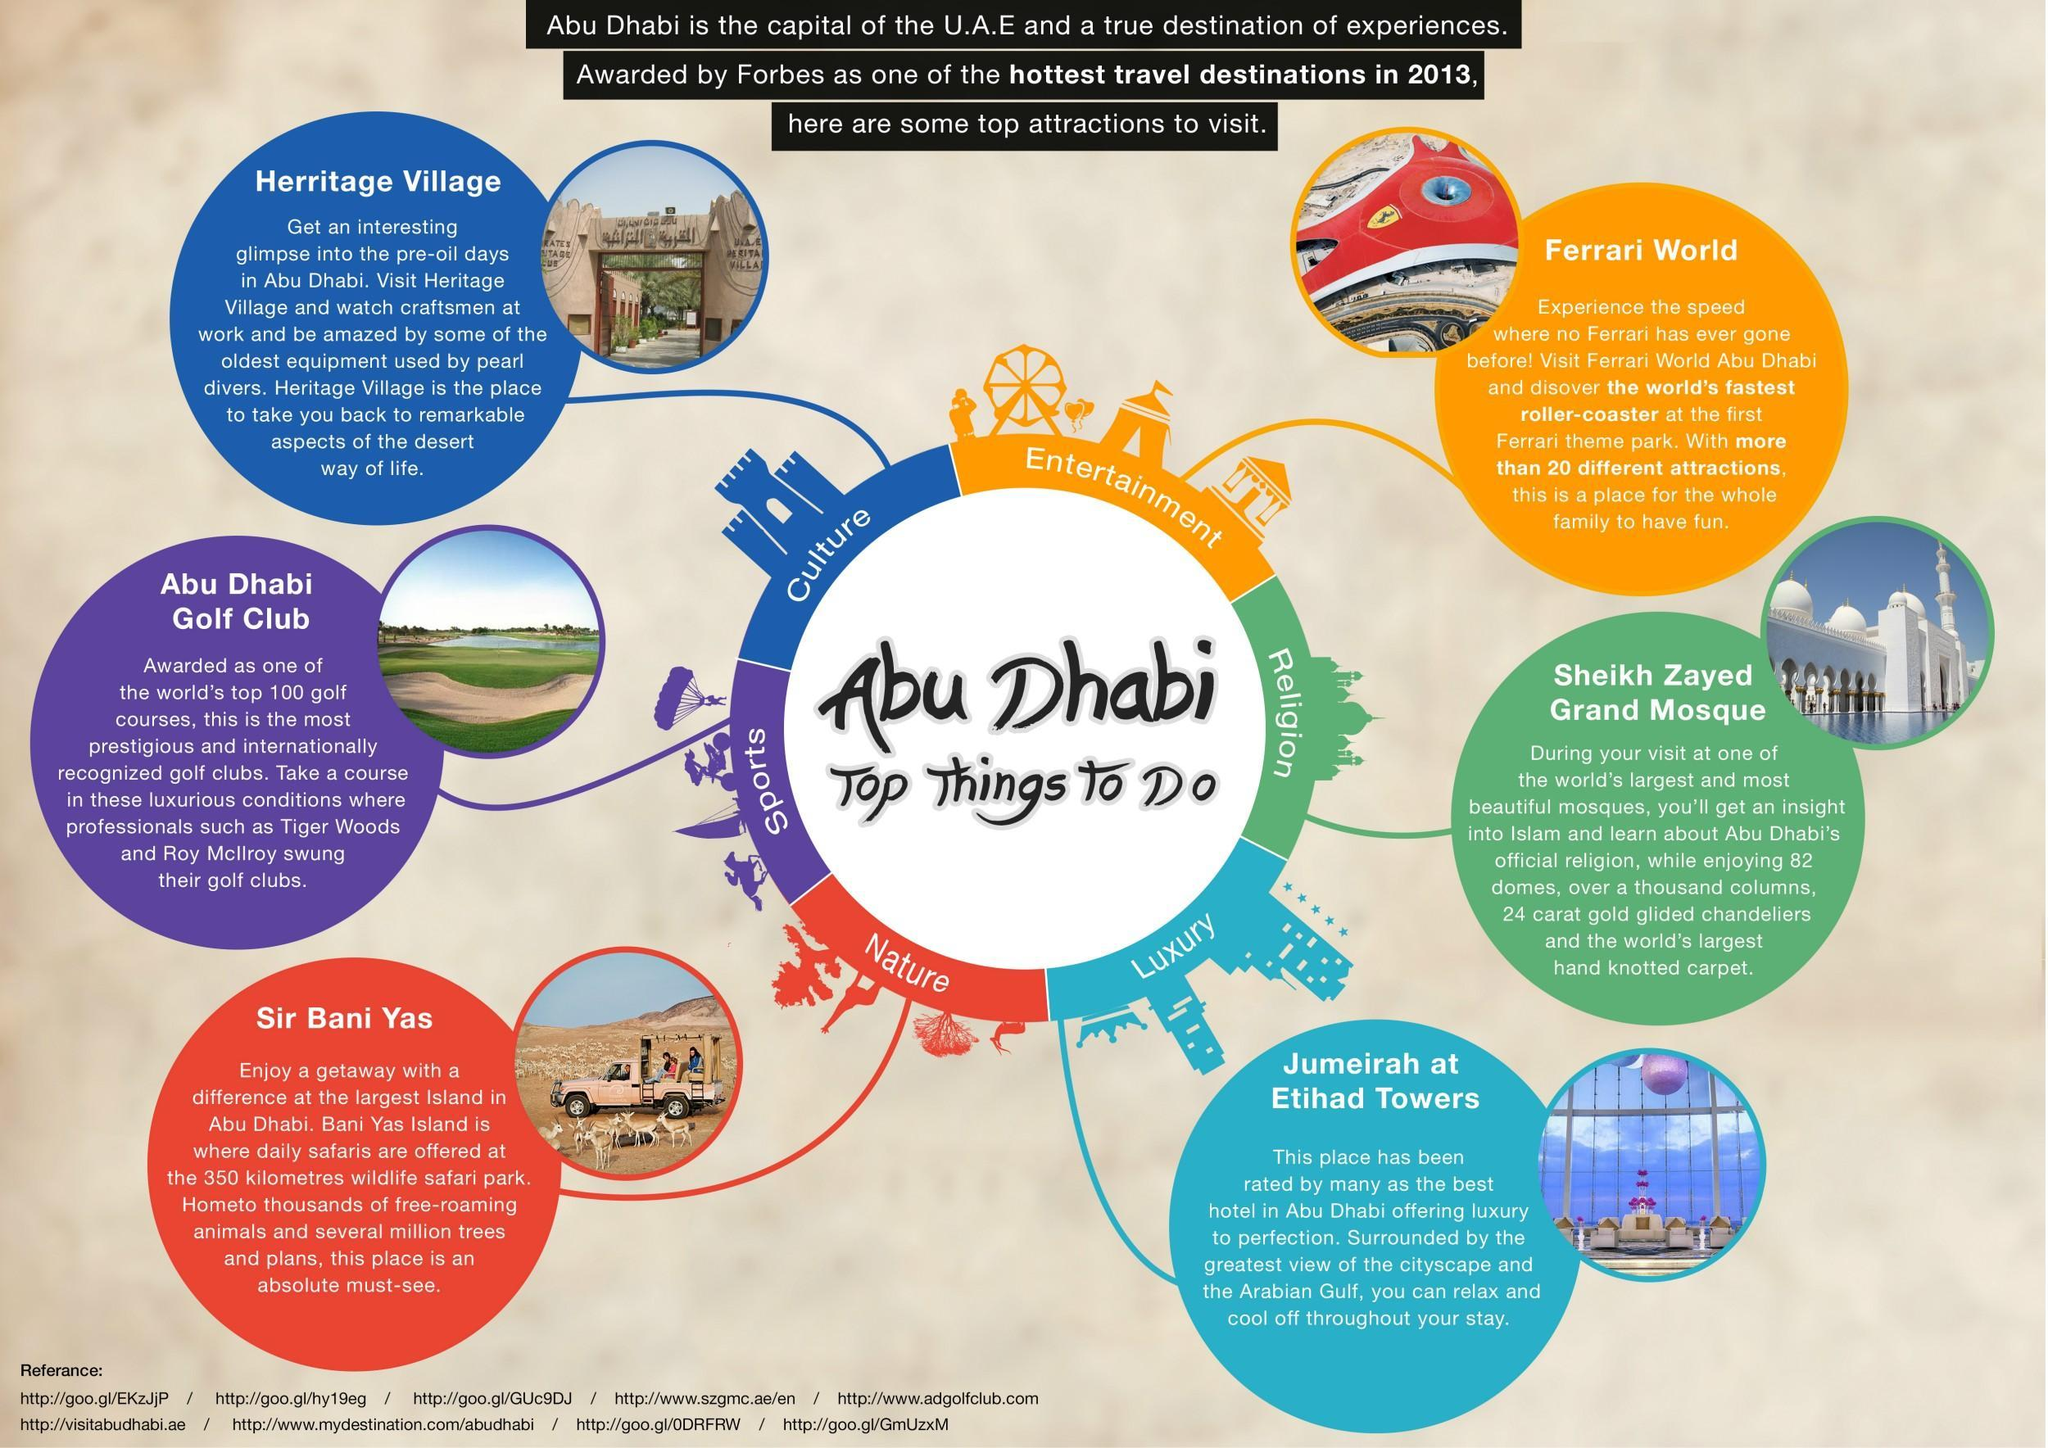How many destinations can be visited in Abu Dhabi?
Answer the question with a short phrase. 6 